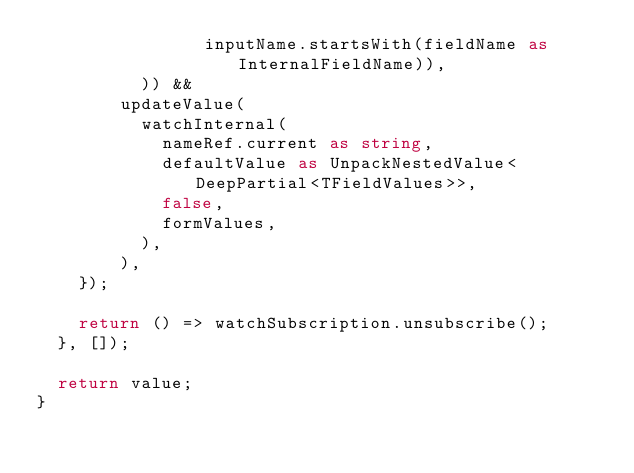<code> <loc_0><loc_0><loc_500><loc_500><_TypeScript_>                inputName.startsWith(fieldName as InternalFieldName)),
          )) &&
        updateValue(
          watchInternal(
            nameRef.current as string,
            defaultValue as UnpackNestedValue<DeepPartial<TFieldValues>>,
            false,
            formValues,
          ),
        ),
    });

    return () => watchSubscription.unsubscribe();
  }, []);

  return value;
}
</code> 